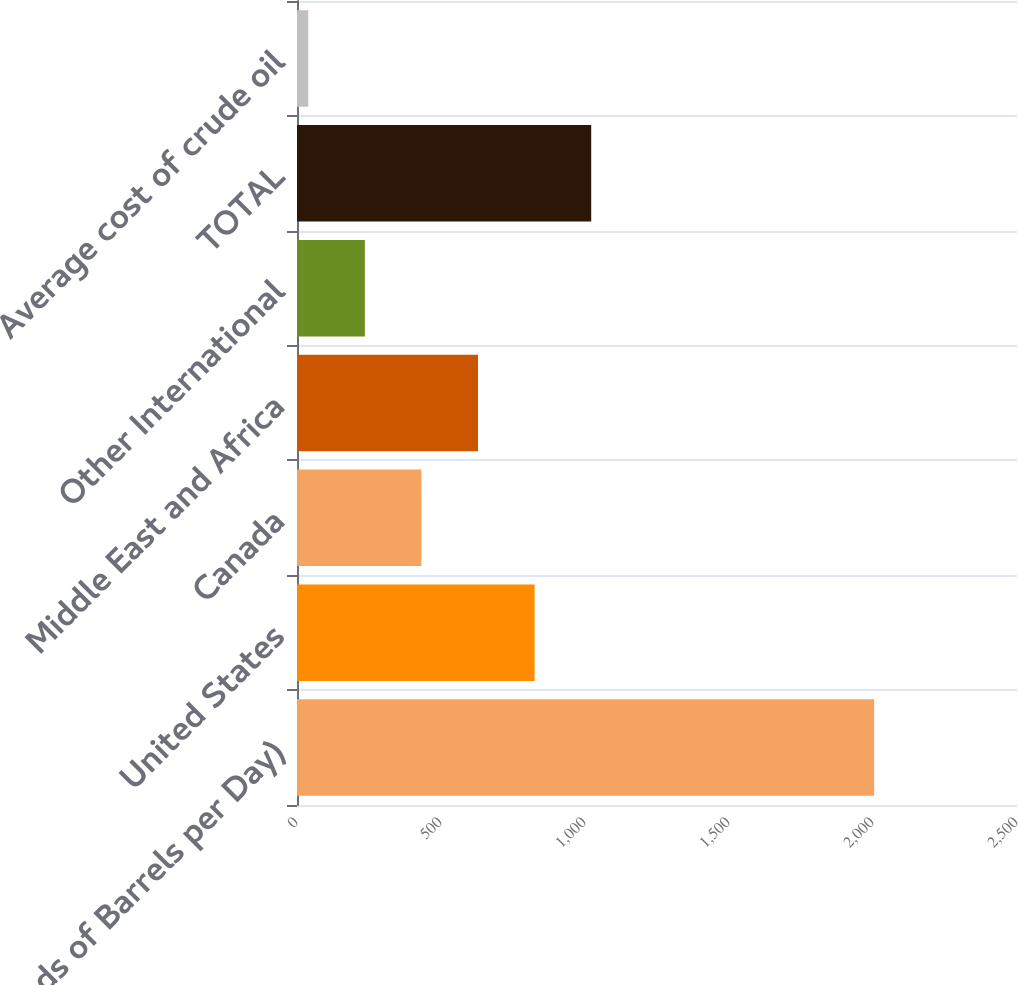<chart> <loc_0><loc_0><loc_500><loc_500><bar_chart><fcel>(Thousands of Barrels per Day)<fcel>United States<fcel>Canada<fcel>Middle East and Africa<fcel>Other International<fcel>TOTAL<fcel>Average cost of crude oil<nl><fcel>2004<fcel>825.08<fcel>432.12<fcel>628.6<fcel>235.64<fcel>1021.56<fcel>39.16<nl></chart> 